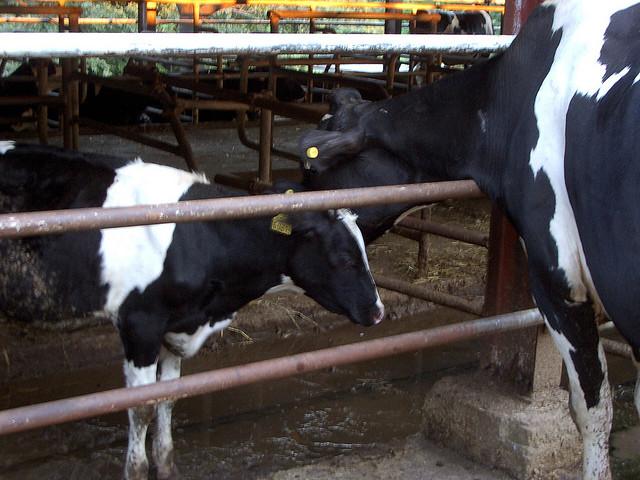Is the fence made of pipes?
Concise answer only. Yes. Why have these animals been tagged?
Answer briefly. To track. Which cow is older?
Quick response, please. One on right. 